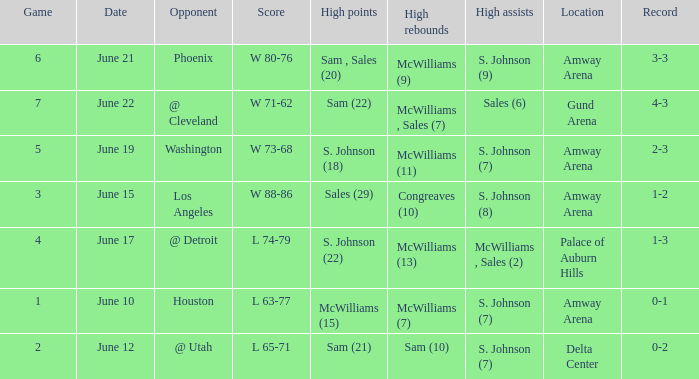Name the opponent for june 12 @ Utah. 